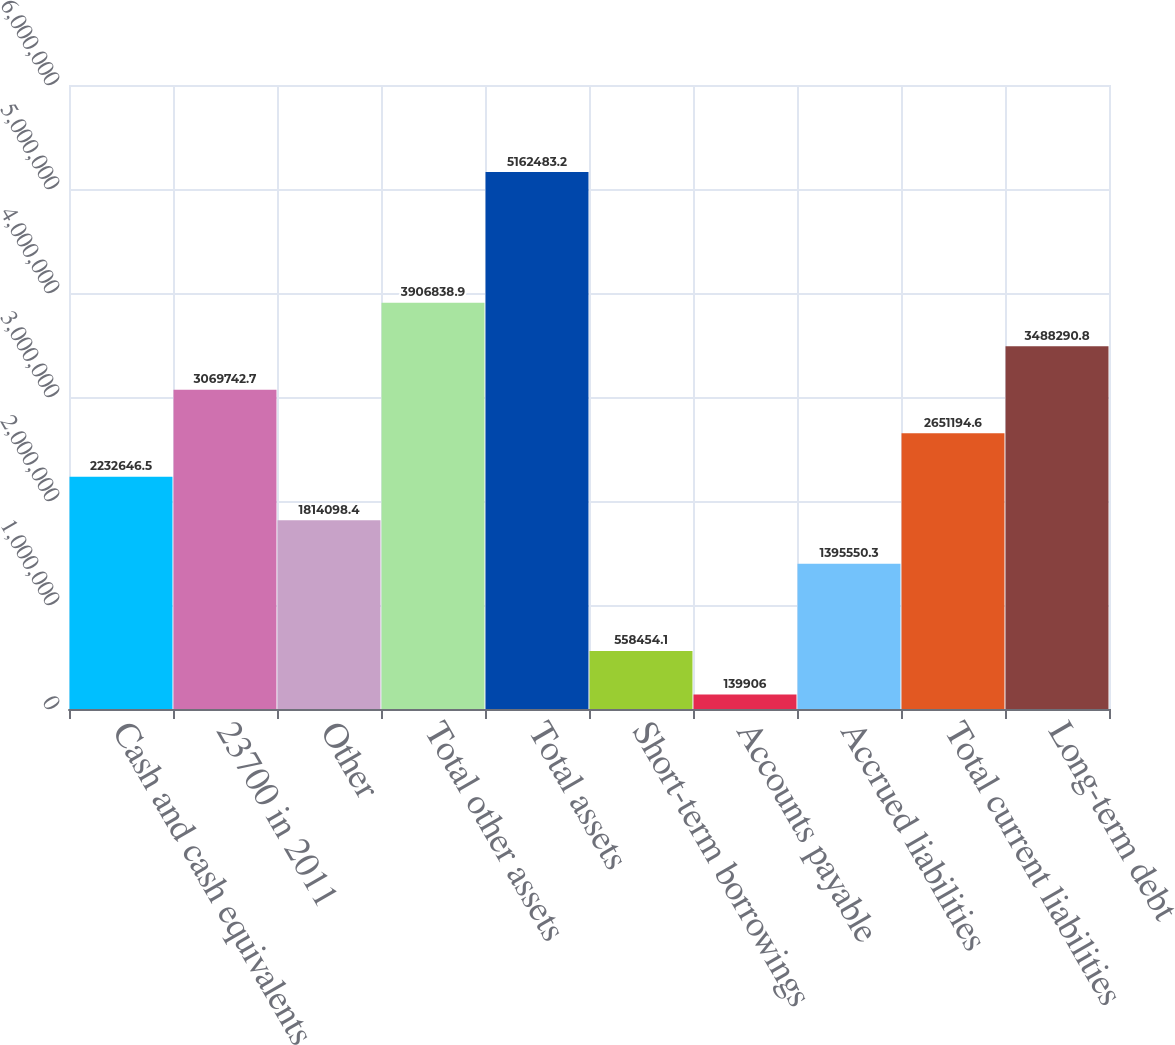<chart> <loc_0><loc_0><loc_500><loc_500><bar_chart><fcel>Cash and cash equivalents<fcel>23700 in 2011<fcel>Other<fcel>Total other assets<fcel>Total assets<fcel>Short-term borrowings<fcel>Accounts payable<fcel>Accrued liabilities<fcel>Total current liabilities<fcel>Long-term debt<nl><fcel>2.23265e+06<fcel>3.06974e+06<fcel>1.8141e+06<fcel>3.90684e+06<fcel>5.16248e+06<fcel>558454<fcel>139906<fcel>1.39555e+06<fcel>2.65119e+06<fcel>3.48829e+06<nl></chart> 